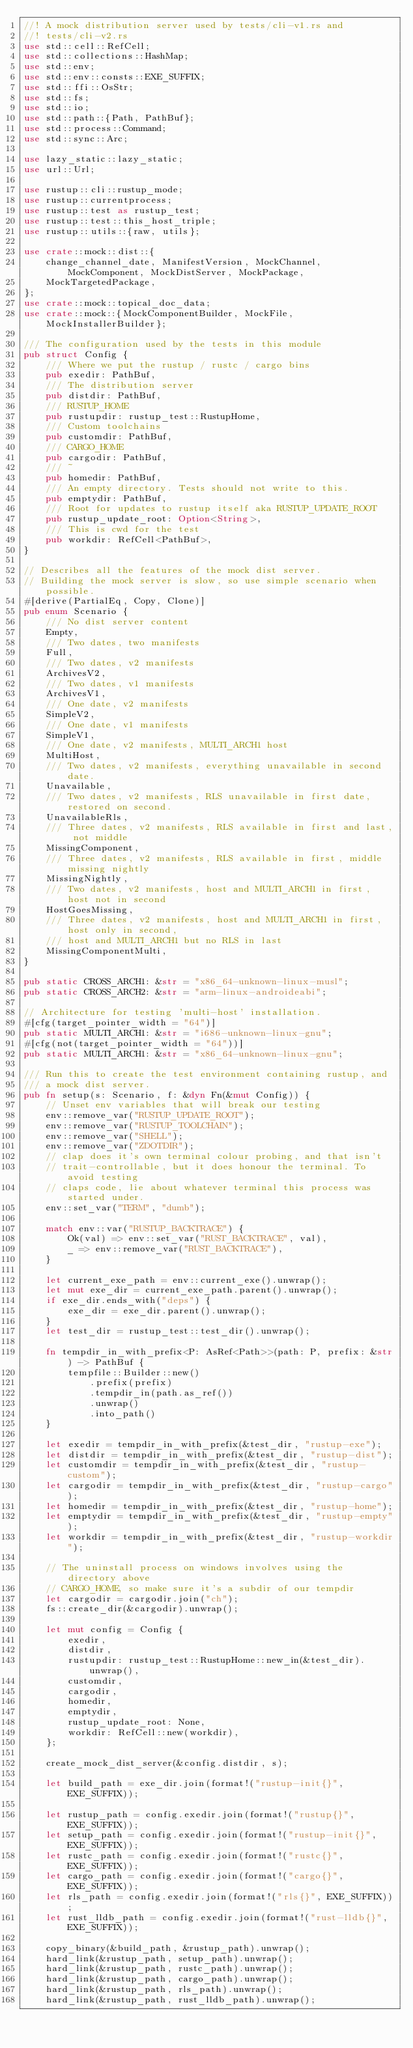<code> <loc_0><loc_0><loc_500><loc_500><_Rust_>//! A mock distribution server used by tests/cli-v1.rs and
//! tests/cli-v2.rs
use std::cell::RefCell;
use std::collections::HashMap;
use std::env;
use std::env::consts::EXE_SUFFIX;
use std::ffi::OsStr;
use std::fs;
use std::io;
use std::path::{Path, PathBuf};
use std::process::Command;
use std::sync::Arc;

use lazy_static::lazy_static;
use url::Url;

use rustup::cli::rustup_mode;
use rustup::currentprocess;
use rustup::test as rustup_test;
use rustup::test::this_host_triple;
use rustup::utils::{raw, utils};

use crate::mock::dist::{
    change_channel_date, ManifestVersion, MockChannel, MockComponent, MockDistServer, MockPackage,
    MockTargetedPackage,
};
use crate::mock::topical_doc_data;
use crate::mock::{MockComponentBuilder, MockFile, MockInstallerBuilder};

/// The configuration used by the tests in this module
pub struct Config {
    /// Where we put the rustup / rustc / cargo bins
    pub exedir: PathBuf,
    /// The distribution server
    pub distdir: PathBuf,
    /// RUSTUP_HOME
    pub rustupdir: rustup_test::RustupHome,
    /// Custom toolchains
    pub customdir: PathBuf,
    /// CARGO_HOME
    pub cargodir: PathBuf,
    /// ~
    pub homedir: PathBuf,
    /// An empty directory. Tests should not write to this.
    pub emptydir: PathBuf,
    /// Root for updates to rustup itself aka RUSTUP_UPDATE_ROOT
    pub rustup_update_root: Option<String>,
    /// This is cwd for the test
    pub workdir: RefCell<PathBuf>,
}

// Describes all the features of the mock dist server.
// Building the mock server is slow, so use simple scenario when possible.
#[derive(PartialEq, Copy, Clone)]
pub enum Scenario {
    /// No dist server content
    Empty,
    /// Two dates, two manifests
    Full,
    /// Two dates, v2 manifests
    ArchivesV2,
    /// Two dates, v1 manifests
    ArchivesV1,
    /// One date, v2 manifests
    SimpleV2,
    /// One date, v1 manifests
    SimpleV1,
    /// One date, v2 manifests, MULTI_ARCH1 host
    MultiHost,
    /// Two dates, v2 manifests, everything unavailable in second date.
    Unavailable,
    /// Two dates, v2 manifests, RLS unavailable in first date, restored on second.
    UnavailableRls,
    /// Three dates, v2 manifests, RLS available in first and last, not middle
    MissingComponent,
    /// Three dates, v2 manifests, RLS available in first, middle missing nightly
    MissingNightly,
    /// Two dates, v2 manifests, host and MULTI_ARCH1 in first, host not in second
    HostGoesMissing,
    /// Three dates, v2 manifests, host and MULTI_ARCH1 in first, host only in second,
    /// host and MULTI_ARCH1 but no RLS in last
    MissingComponentMulti,
}

pub static CROSS_ARCH1: &str = "x86_64-unknown-linux-musl";
pub static CROSS_ARCH2: &str = "arm-linux-androideabi";

// Architecture for testing 'multi-host' installation.
#[cfg(target_pointer_width = "64")]
pub static MULTI_ARCH1: &str = "i686-unknown-linux-gnu";
#[cfg(not(target_pointer_width = "64"))]
pub static MULTI_ARCH1: &str = "x86_64-unknown-linux-gnu";

/// Run this to create the test environment containing rustup, and
/// a mock dist server.
pub fn setup(s: Scenario, f: &dyn Fn(&mut Config)) {
    // Unset env variables that will break our testing
    env::remove_var("RUSTUP_UPDATE_ROOT");
    env::remove_var("RUSTUP_TOOLCHAIN");
    env::remove_var("SHELL");
    env::remove_var("ZDOTDIR");
    // clap does it's own terminal colour probing, and that isn't
    // trait-controllable, but it does honour the terminal. To avoid testing
    // claps code, lie about whatever terminal this process was started under.
    env::set_var("TERM", "dumb");

    match env::var("RUSTUP_BACKTRACE") {
        Ok(val) => env::set_var("RUST_BACKTRACE", val),
        _ => env::remove_var("RUST_BACKTRACE"),
    }

    let current_exe_path = env::current_exe().unwrap();
    let mut exe_dir = current_exe_path.parent().unwrap();
    if exe_dir.ends_with("deps") {
        exe_dir = exe_dir.parent().unwrap();
    }
    let test_dir = rustup_test::test_dir().unwrap();

    fn tempdir_in_with_prefix<P: AsRef<Path>>(path: P, prefix: &str) -> PathBuf {
        tempfile::Builder::new()
            .prefix(prefix)
            .tempdir_in(path.as_ref())
            .unwrap()
            .into_path()
    }

    let exedir = tempdir_in_with_prefix(&test_dir, "rustup-exe");
    let distdir = tempdir_in_with_prefix(&test_dir, "rustup-dist");
    let customdir = tempdir_in_with_prefix(&test_dir, "rustup-custom");
    let cargodir = tempdir_in_with_prefix(&test_dir, "rustup-cargo");
    let homedir = tempdir_in_with_prefix(&test_dir, "rustup-home");
    let emptydir = tempdir_in_with_prefix(&test_dir, "rustup-empty");
    let workdir = tempdir_in_with_prefix(&test_dir, "rustup-workdir");

    // The uninstall process on windows involves using the directory above
    // CARGO_HOME, so make sure it's a subdir of our tempdir
    let cargodir = cargodir.join("ch");
    fs::create_dir(&cargodir).unwrap();

    let mut config = Config {
        exedir,
        distdir,
        rustupdir: rustup_test::RustupHome::new_in(&test_dir).unwrap(),
        customdir,
        cargodir,
        homedir,
        emptydir,
        rustup_update_root: None,
        workdir: RefCell::new(workdir),
    };

    create_mock_dist_server(&config.distdir, s);

    let build_path = exe_dir.join(format!("rustup-init{}", EXE_SUFFIX));

    let rustup_path = config.exedir.join(format!("rustup{}", EXE_SUFFIX));
    let setup_path = config.exedir.join(format!("rustup-init{}", EXE_SUFFIX));
    let rustc_path = config.exedir.join(format!("rustc{}", EXE_SUFFIX));
    let cargo_path = config.exedir.join(format!("cargo{}", EXE_SUFFIX));
    let rls_path = config.exedir.join(format!("rls{}", EXE_SUFFIX));
    let rust_lldb_path = config.exedir.join(format!("rust-lldb{}", EXE_SUFFIX));

    copy_binary(&build_path, &rustup_path).unwrap();
    hard_link(&rustup_path, setup_path).unwrap();
    hard_link(&rustup_path, rustc_path).unwrap();
    hard_link(&rustup_path, cargo_path).unwrap();
    hard_link(&rustup_path, rls_path).unwrap();
    hard_link(&rustup_path, rust_lldb_path).unwrap();
</code> 